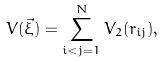<formula> <loc_0><loc_0><loc_500><loc_500>V ( { \vec { \xi } } ) = \sum _ { i < j = 1 } ^ { N } V _ { 2 } ( r _ { i j } ) ,</formula> 